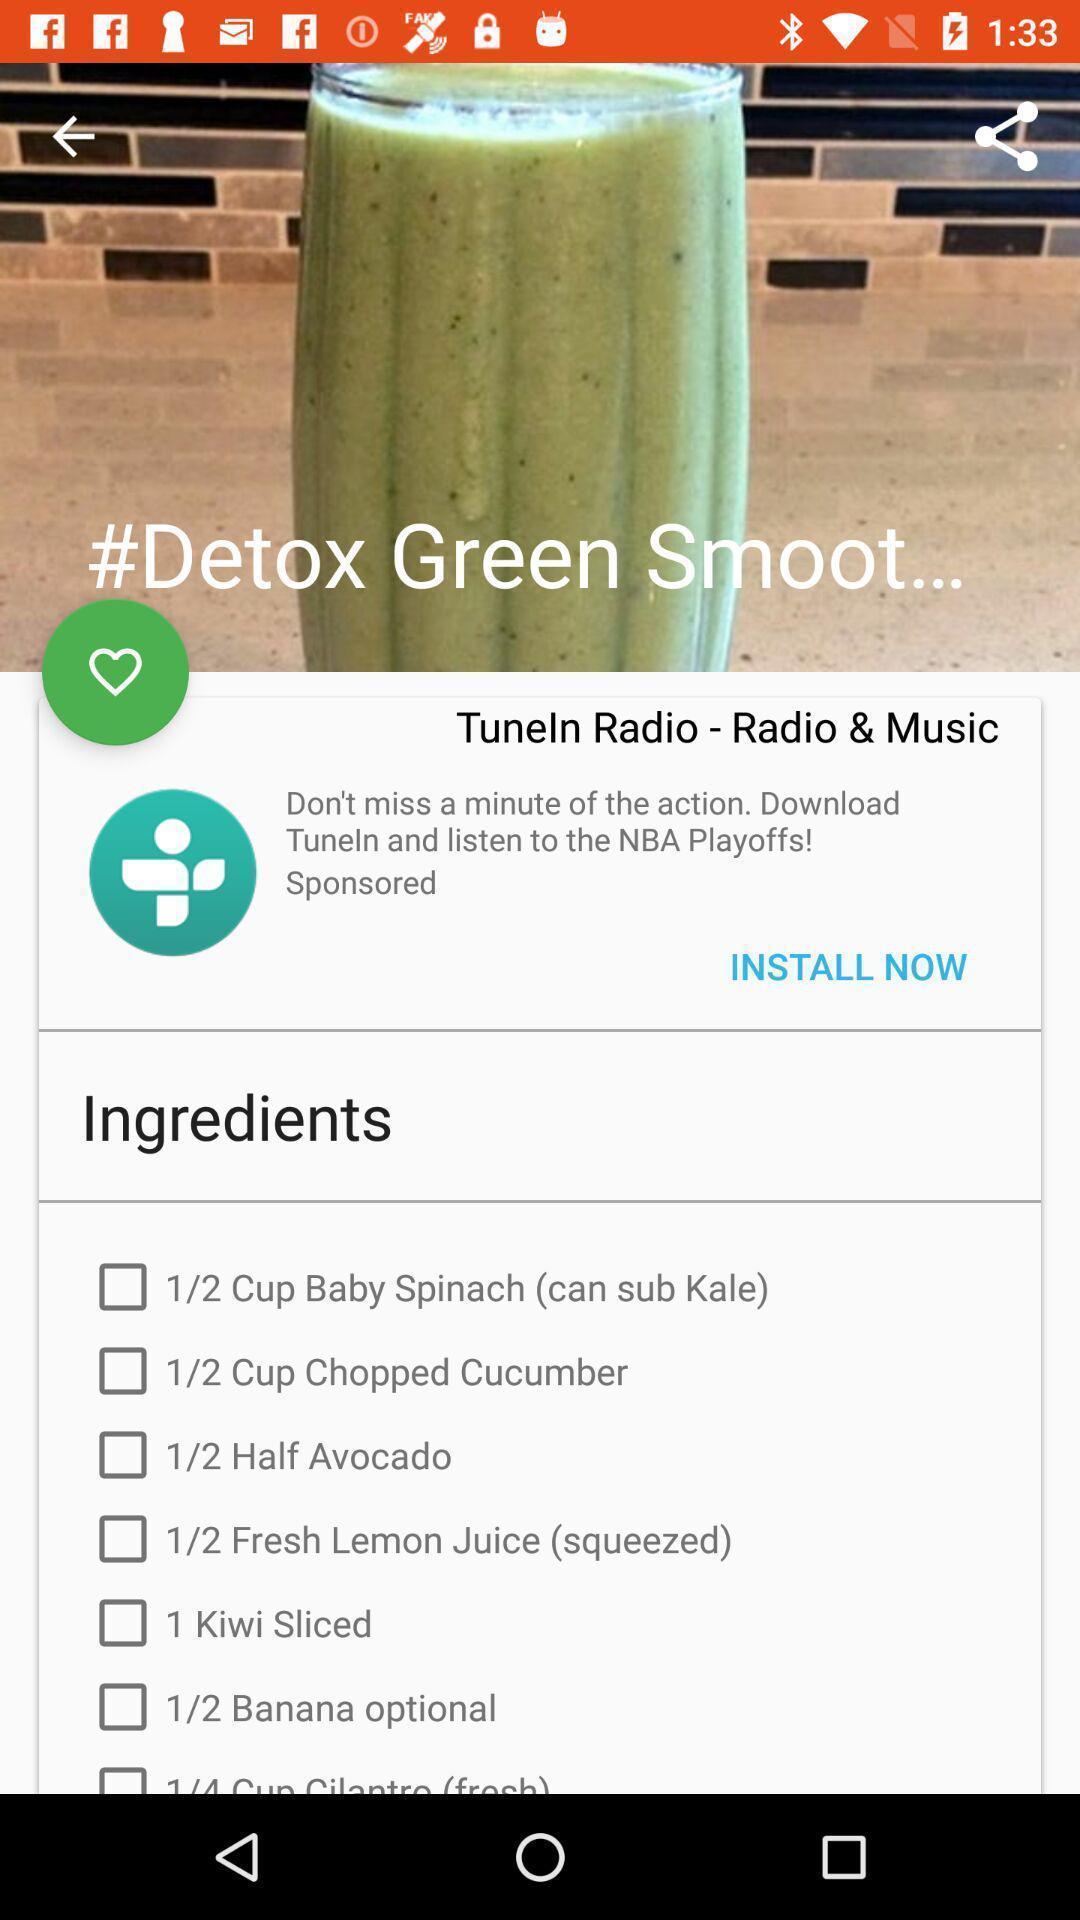Explain what's happening in this screen capture. Page displaying the ingredients of detox green smooth. 